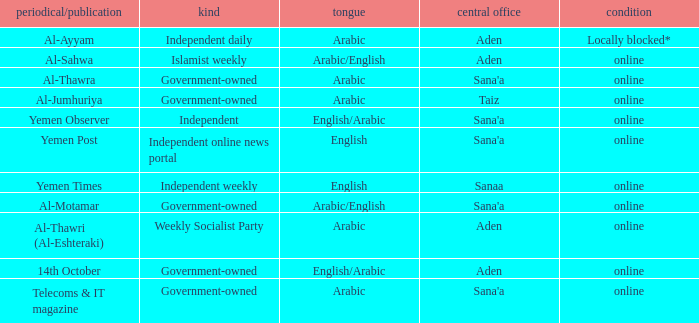What is Headquarter, when Type is Independent Online News Portal? Sana'a. 